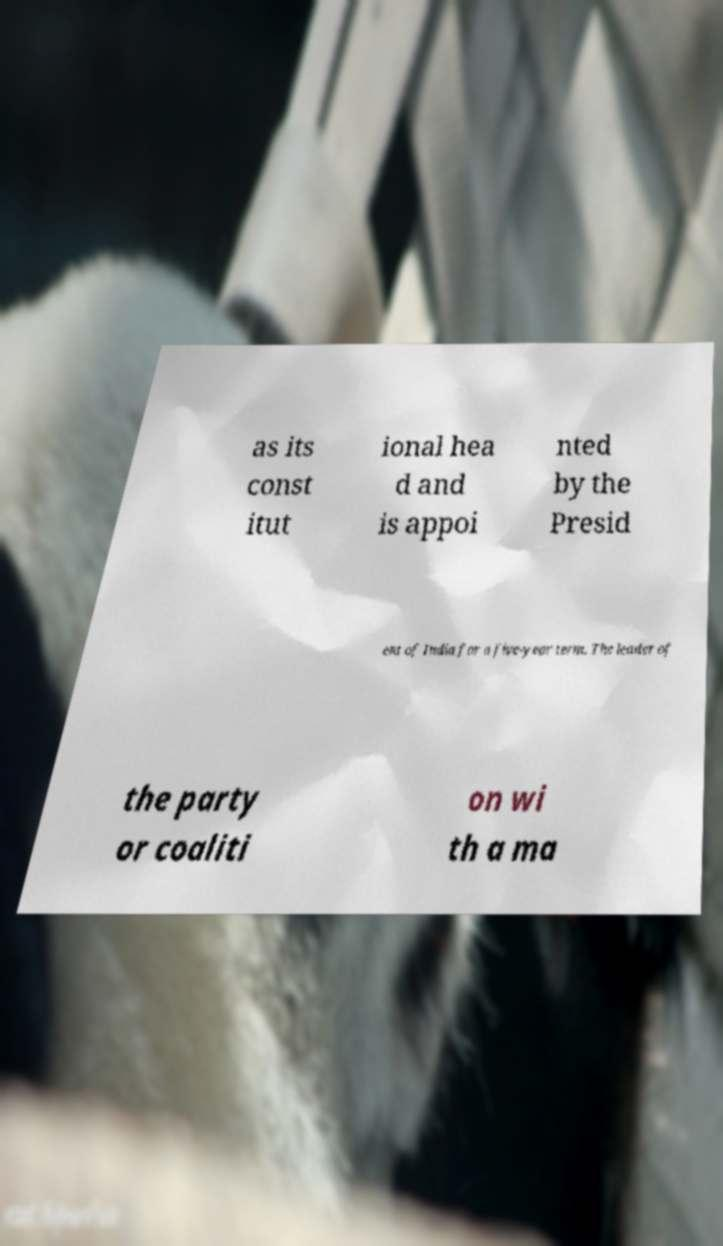I need the written content from this picture converted into text. Can you do that? as its const itut ional hea d and is appoi nted by the Presid ent of India for a five-year term. The leader of the party or coaliti on wi th a ma 